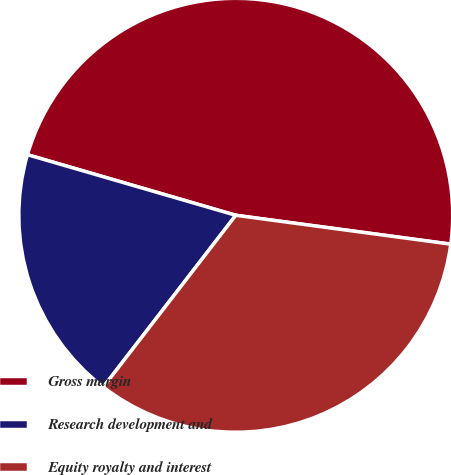Convert chart to OTSL. <chart><loc_0><loc_0><loc_500><loc_500><pie_chart><fcel>Gross margin<fcel>Research development and<fcel>Equity royalty and interest<nl><fcel>47.62%<fcel>19.05%<fcel>33.33%<nl></chart> 